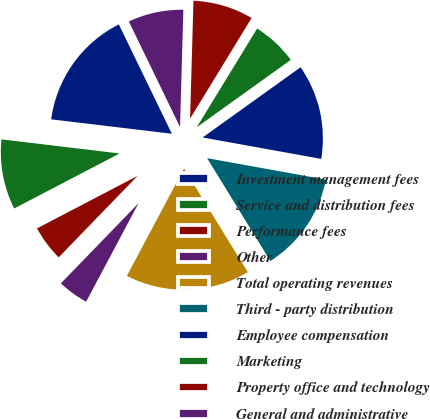Convert chart to OTSL. <chart><loc_0><loc_0><loc_500><loc_500><pie_chart><fcel>Investment management fees<fcel>Service and distribution fees<fcel>Performance fees<fcel>Other<fcel>Total operating revenues<fcel>Third - party distribution<fcel>Employee compensation<fcel>Marketing<fcel>Property office and technology<fcel>General and administrative<nl><fcel>15.92%<fcel>9.55%<fcel>5.1%<fcel>4.46%<fcel>16.56%<fcel>13.38%<fcel>12.74%<fcel>6.37%<fcel>8.28%<fcel>7.64%<nl></chart> 